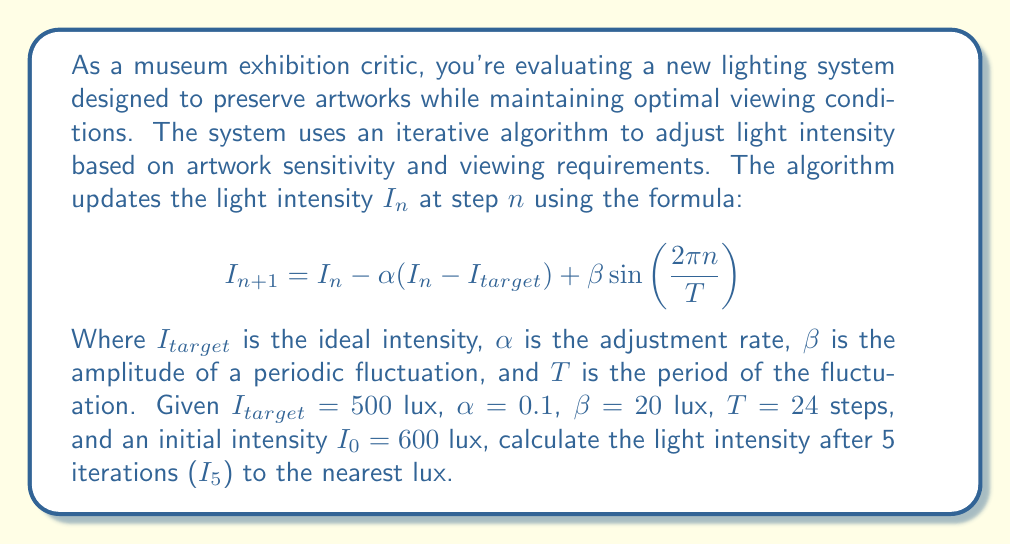Help me with this question. To solve this problem, we need to apply the given formula iteratively for 5 steps. Let's break it down step by step:

1) First, let's identify our constants:
   $I_{target} = 500$ lux
   $\alpha = 0.1$
   $\beta = 20$ lux
   $T = 24$ steps
   $I_0 = 600$ lux

2) Now, let's calculate each iteration:

   For $n = 0$ (to get $I_1$):
   $$I_1 = 600 - 0.1(600 - 500) + 20\sin(\frac{2\pi \cdot 0}{24}) = 590 + 0 = 590$$

   For $n = 1$ (to get $I_2$):
   $$I_2 = 590 - 0.1(590 - 500) + 20\sin(\frac{2\pi \cdot 1}{24}) = 581 + 5.18 = 586.18$$

   For $n = 2$ (to get $I_3$):
   $$I_3 = 586.18 - 0.1(586.18 - 500) + 20\sin(\frac{2\pi \cdot 2}{24}) = 577.56 + 10 = 587.56$$

   For $n = 3$ (to get $I_4$):
   $$I_4 = 587.56 - 0.1(587.56 - 500) + 20\sin(\frac{2\pi \cdot 3}{24}) = 578.80 + 13.86 = 592.66$$

   For $n = 4$ (to get $I_5$):
   $$I_5 = 592.66 - 0.1(592.66 - 500) + 20\sin(\frac{2\pi \cdot 4}{24}) = 583.39 + 16.60 = 599.99$$

3) Rounding to the nearest lux, we get 600 lux.

This result shows that the lighting system is oscillating around the target intensity, which is typical for this type of control algorithm. The periodic fluctuation term adds a subtle variation that might be designed to mimic natural light changes or to provide periodic relief for sensitive artworks.
Answer: 600 lux 